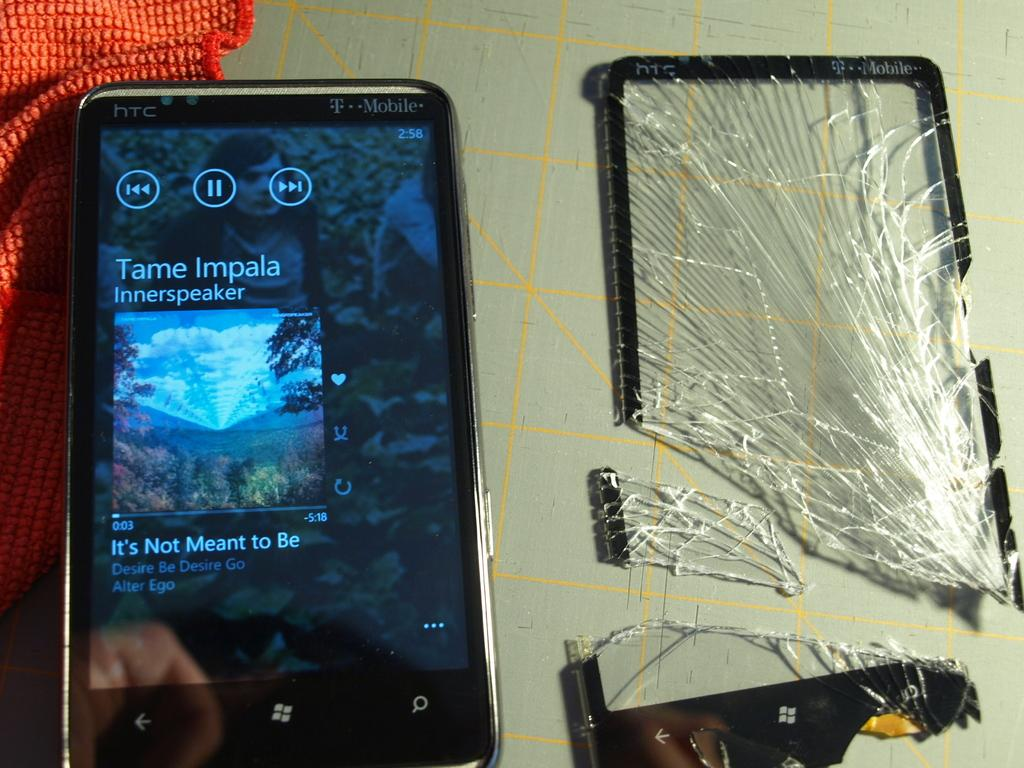What type of furniture is present in the image? There is a table in the image. What is covering the table? There is a cloth on the table. What electronic device can be seen on the table? There is a mobile phone on the table. What type of dishware is present on the table? There are glasses on the table. How many cars are parked on the table in the image? There are no cars present on the table in the image. Is there a hat on the table in the image? There is no hat present on the table in the image. 